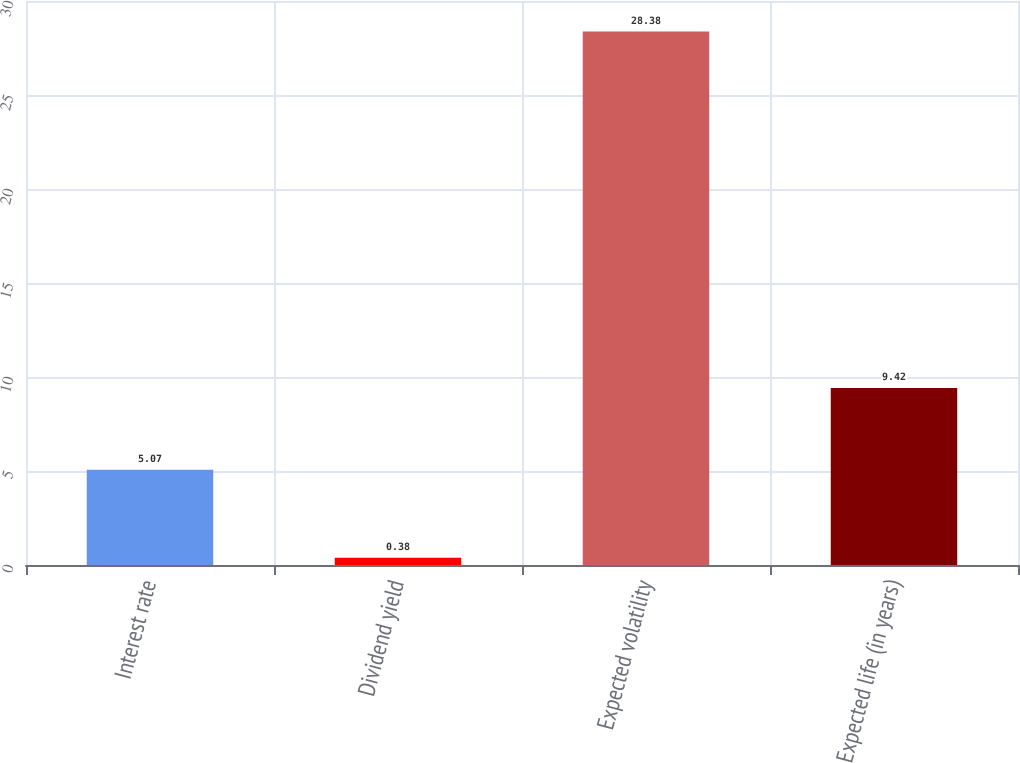Convert chart to OTSL. <chart><loc_0><loc_0><loc_500><loc_500><bar_chart><fcel>Interest rate<fcel>Dividend yield<fcel>Expected volatility<fcel>Expected life (in years)<nl><fcel>5.07<fcel>0.38<fcel>28.38<fcel>9.42<nl></chart> 